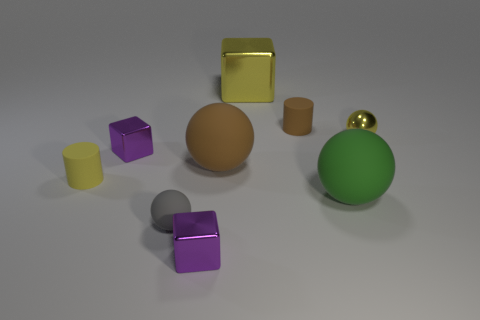Are there more cyan matte cylinders than brown rubber cylinders?
Offer a terse response. No. Is the brown thing on the left side of the tiny brown matte cylinder made of the same material as the tiny sphere that is behind the large green rubber ball?
Offer a very short reply. No. What is the yellow block made of?
Offer a very short reply. Metal. Is the number of large green balls on the right side of the large metal block greater than the number of cyan rubber objects?
Give a very brief answer. Yes. There is a cylinder that is left of the tiny matte cylinder that is behind the big brown object; what number of objects are behind it?
Make the answer very short. 5. What is the big thing that is behind the small yellow rubber cylinder and in front of the yellow sphere made of?
Offer a terse response. Rubber. What color is the tiny metallic ball?
Offer a terse response. Yellow. Is the number of small yellow things that are to the left of the tiny brown thing greater than the number of small yellow metallic objects behind the yellow metallic ball?
Keep it short and to the point. Yes. What is the color of the large rubber sphere in front of the brown sphere?
Provide a short and direct response. Green. There is a purple cube that is in front of the brown ball; is it the same size as the thing behind the brown rubber cylinder?
Your response must be concise. No. 